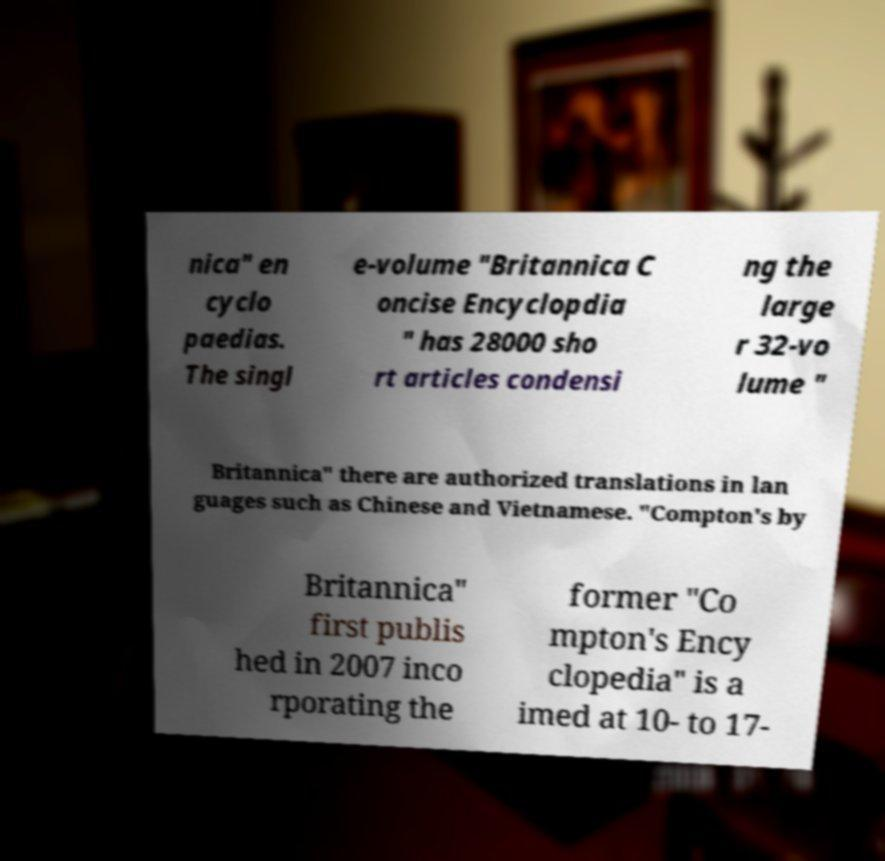Can you read and provide the text displayed in the image?This photo seems to have some interesting text. Can you extract and type it out for me? nica" en cyclo paedias. The singl e-volume "Britannica C oncise Encyclopdia " has 28000 sho rt articles condensi ng the large r 32-vo lume " Britannica" there are authorized translations in lan guages such as Chinese and Vietnamese. "Compton's by Britannica" first publis hed in 2007 inco rporating the former "Co mpton's Ency clopedia" is a imed at 10- to 17- 